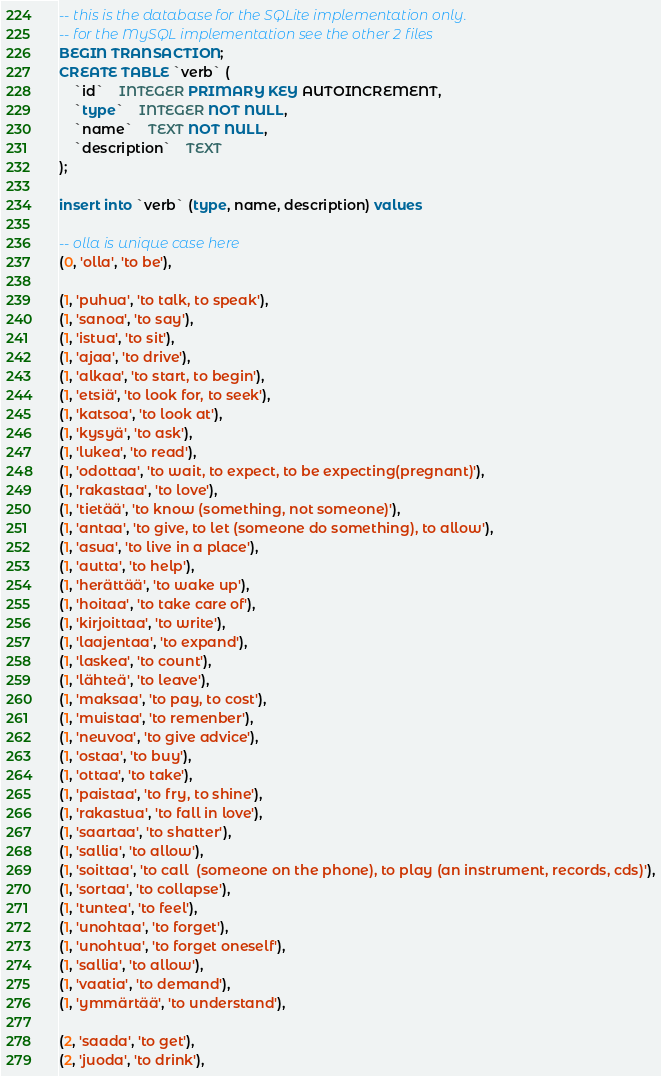<code> <loc_0><loc_0><loc_500><loc_500><_SQL_>-- this is the database for the SQLite implementation only.
-- for the MySQL implementation see the other 2 files
BEGIN TRANSACTION;
CREATE TABLE `verb` (
	`id`	INTEGER PRIMARY KEY AUTOINCREMENT,
	`type`	INTEGER NOT NULL,
	`name`	TEXT NOT NULL,
	`description`	TEXT
);

insert into `verb` (type, name, description) values

-- olla is unique case here
(0, 'olla', 'to be'),

(1, 'puhua', 'to talk, to speak'),
(1, 'sanoa', 'to say'),
(1, 'istua', 'to sit'),
(1, 'ajaa', 'to drive'),
(1, 'alkaa', 'to start, to begin'),
(1, 'etsiä', 'to look for, to seek'),
(1, 'katsoa', 'to look at'),
(1, 'kysyä', 'to ask'),
(1, 'lukea', 'to read'),
(1, 'odottaa', 'to wait, to expect, to be expecting(pregnant)'),
(1, 'rakastaa', 'to love'),
(1, 'tietää', 'to know (something, not someone)'),
(1, 'antaa', 'to give, to let (someone do something), to allow'),
(1, 'asua', 'to live in a place'),
(1, 'autta', 'to help'),
(1, 'herättää', 'to wake up'),
(1, 'hoitaa', 'to take care of'),
(1, 'kirjoittaa', 'to write'),
(1, 'laajentaa', 'to expand'),
(1, 'laskea', 'to count'),
(1, 'lähteä', 'to leave'),
(1, 'maksaa', 'to pay, to cost'),
(1, 'muistaa', 'to remenber'),
(1, 'neuvoa', 'to give advice'),
(1, 'ostaa', 'to buy'),
(1, 'ottaa', 'to take'),
(1, 'paistaa', 'to fry, to shine'),
(1, 'rakastua', 'to fall in love'),
(1, 'saartaa', 'to shatter'),
(1, 'sallia', 'to allow'),
(1, 'soittaa', 'to call  (someone on the phone), to play (an instrument, records, cds)'),
(1, 'sortaa', 'to collapse'),
(1, 'tuntea', 'to feel'),
(1, 'unohtaa', 'to forget'),
(1, 'unohtua', 'to forget oneself'),
(1, 'sallia', 'to allow'),
(1, 'vaatia', 'to demand'),
(1, 'ymmärtää', 'to understand'),

(2, 'saada', 'to get'),
(2, 'juoda', 'to drink'),</code> 